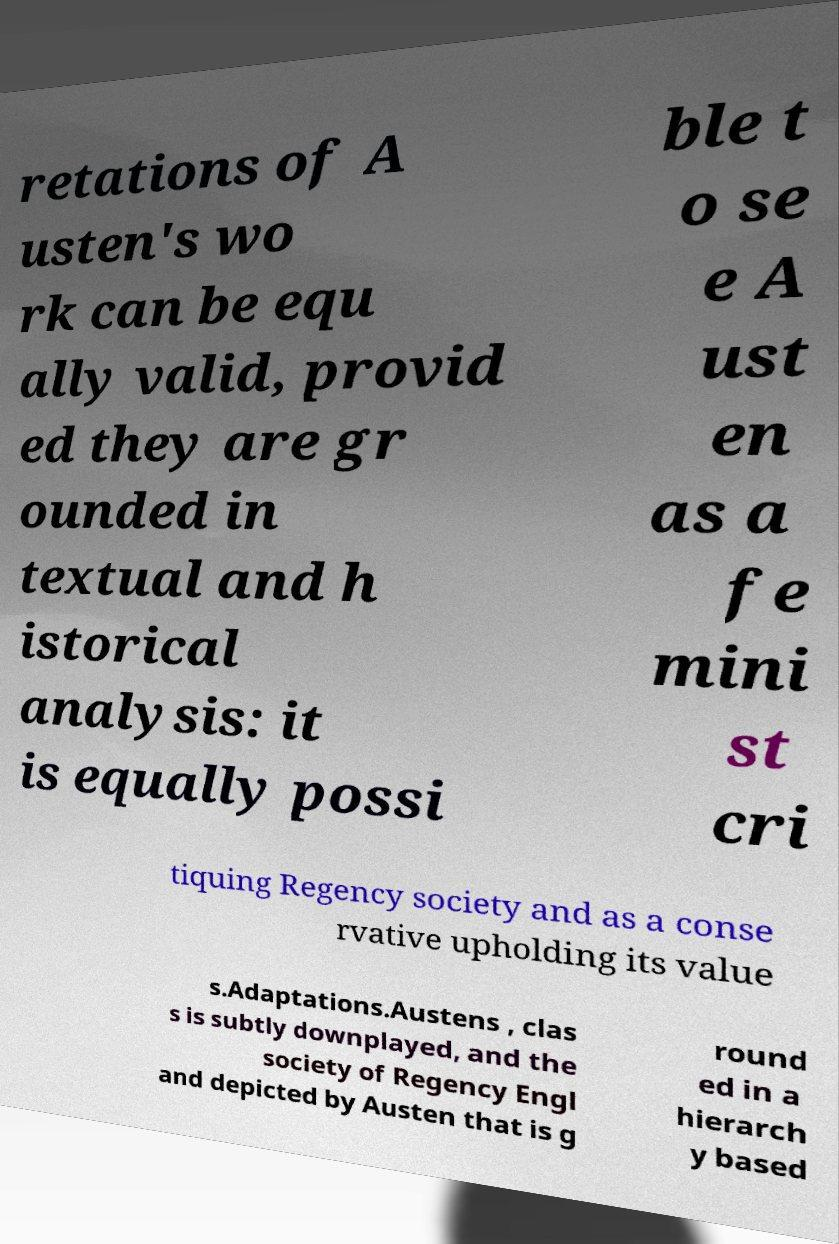I need the written content from this picture converted into text. Can you do that? retations of A usten's wo rk can be equ ally valid, provid ed they are gr ounded in textual and h istorical analysis: it is equally possi ble t o se e A ust en as a fe mini st cri tiquing Regency society and as a conse rvative upholding its value s.Adaptations.Austens , clas s is subtly downplayed, and the society of Regency Engl and depicted by Austen that is g round ed in a hierarch y based 